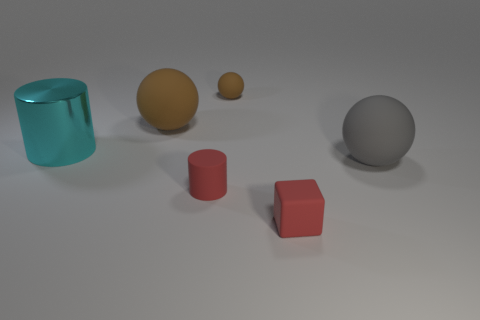Does the big ball that is left of the large gray matte object have the same color as the tiny matte sphere?
Offer a very short reply. Yes. What shape is the small matte object that is right of the brown matte ball that is behind the big ball that is behind the gray matte thing?
Provide a short and direct response. Cube. Are there any brown spheres that have the same material as the red block?
Ensure brevity in your answer.  Yes. There is a tiny thing that is on the left side of the tiny rubber sphere; does it have the same color as the tiny cube on the right side of the large cyan metal cylinder?
Keep it short and to the point. Yes. Is the number of tiny cylinders on the right side of the small block less than the number of big matte objects?
Your answer should be very brief. Yes. What number of things are big red rubber cubes or big objects that are behind the gray rubber object?
Your response must be concise. 2. There is a tiny cube that is the same material as the large brown ball; what is its color?
Ensure brevity in your answer.  Red. What number of things are tiny brown objects or balls?
Provide a succinct answer. 3. What is the color of the matte ball that is the same size as the red matte block?
Offer a terse response. Brown. What number of objects are brown balls in front of the small rubber sphere or tiny blue things?
Your answer should be compact. 1. 